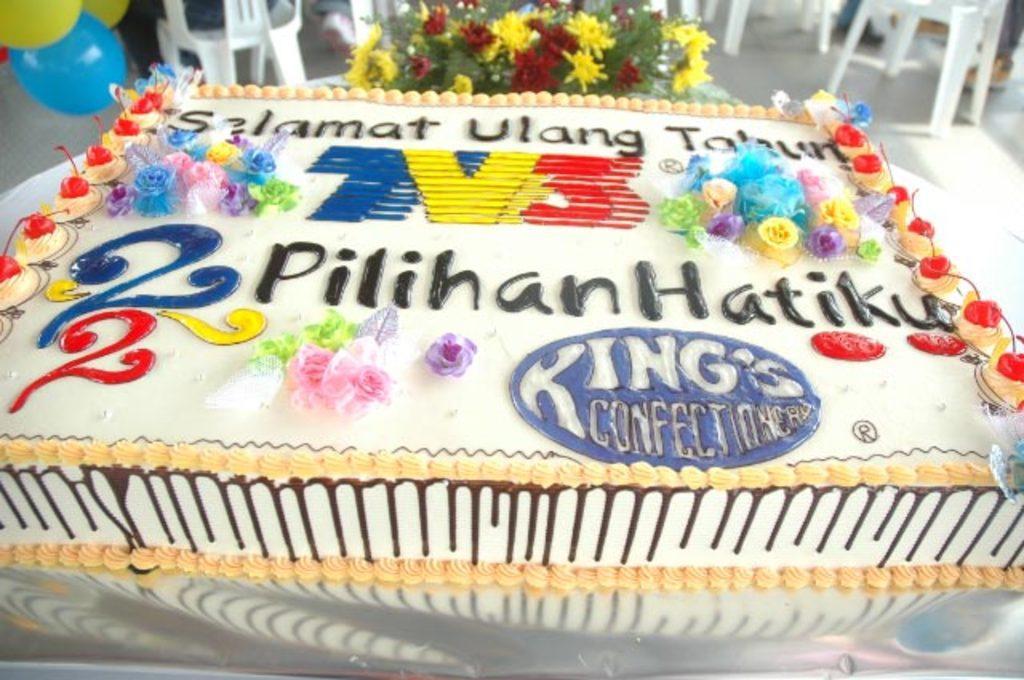In one or two sentences, can you explain what this image depicts? Here I can see a cake on a table which is covered with a white cloth. On the cake I can see some text. On the top of the image there are some chairs, balloons and flowers. 